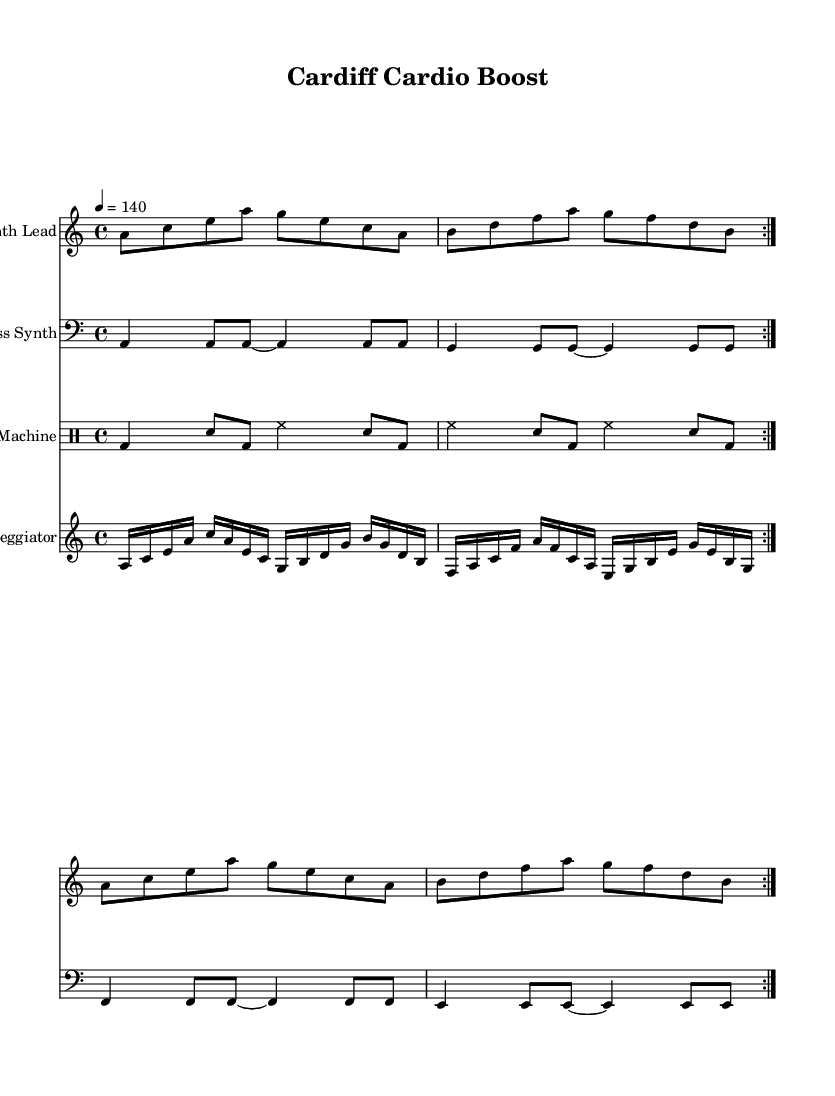What is the key signature of this music? The key signature is A minor, which is indicated by the presence of no sharps or flats in the key signature area.
Answer: A minor What is the time signature of this music? The time signature shown is 4/4, which means there are four beats in each measure and each quarter note receives one beat.
Answer: 4/4 What is the tempo of this piece? The tempo marking states "4 = 140," which indicates that there are 140 beats per minute.
Answer: 140 How many times is the synth lead repeated? The synth lead has a "volta" marking indicating it is repeated twice, which is explicitly noted in the score as "repeat volta 2."
Answer: 2 What is the tempo marking used in this music? The tempo marking provided is a quarter note equals 140 beats per minute, commonly referred to as "quarter note = 140."
Answer: quarter note = 140 What type of synthesizer is featured as the lead instrument? The lead instrument is referred to as "Synth Lead," specifically noted in the instrument name of the corresponding staff.
Answer: Synth Lead What is unique about the drum machine notation? The drum machine uses a drummode specific style of notation, allowing for distinct representation of different percussion sounds, indicated as "drummode" in the score.
Answer: drummode 